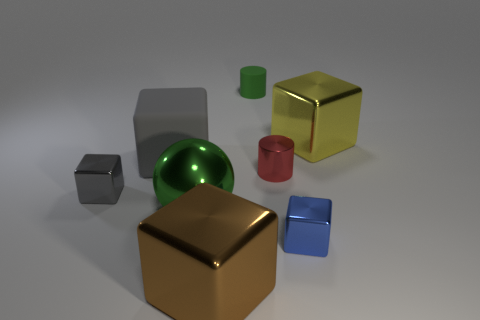Subtract all blue blocks. How many blocks are left? 4 Subtract all large brown metal blocks. How many blocks are left? 4 Subtract all purple cubes. Subtract all blue cylinders. How many cubes are left? 5 Add 1 gray rubber cubes. How many objects exist? 9 Subtract all spheres. How many objects are left? 7 Subtract all large brown metallic blocks. Subtract all yellow metallic things. How many objects are left? 6 Add 5 blue cubes. How many blue cubes are left? 6 Add 1 brown metallic balls. How many brown metallic balls exist? 1 Subtract 0 purple blocks. How many objects are left? 8 